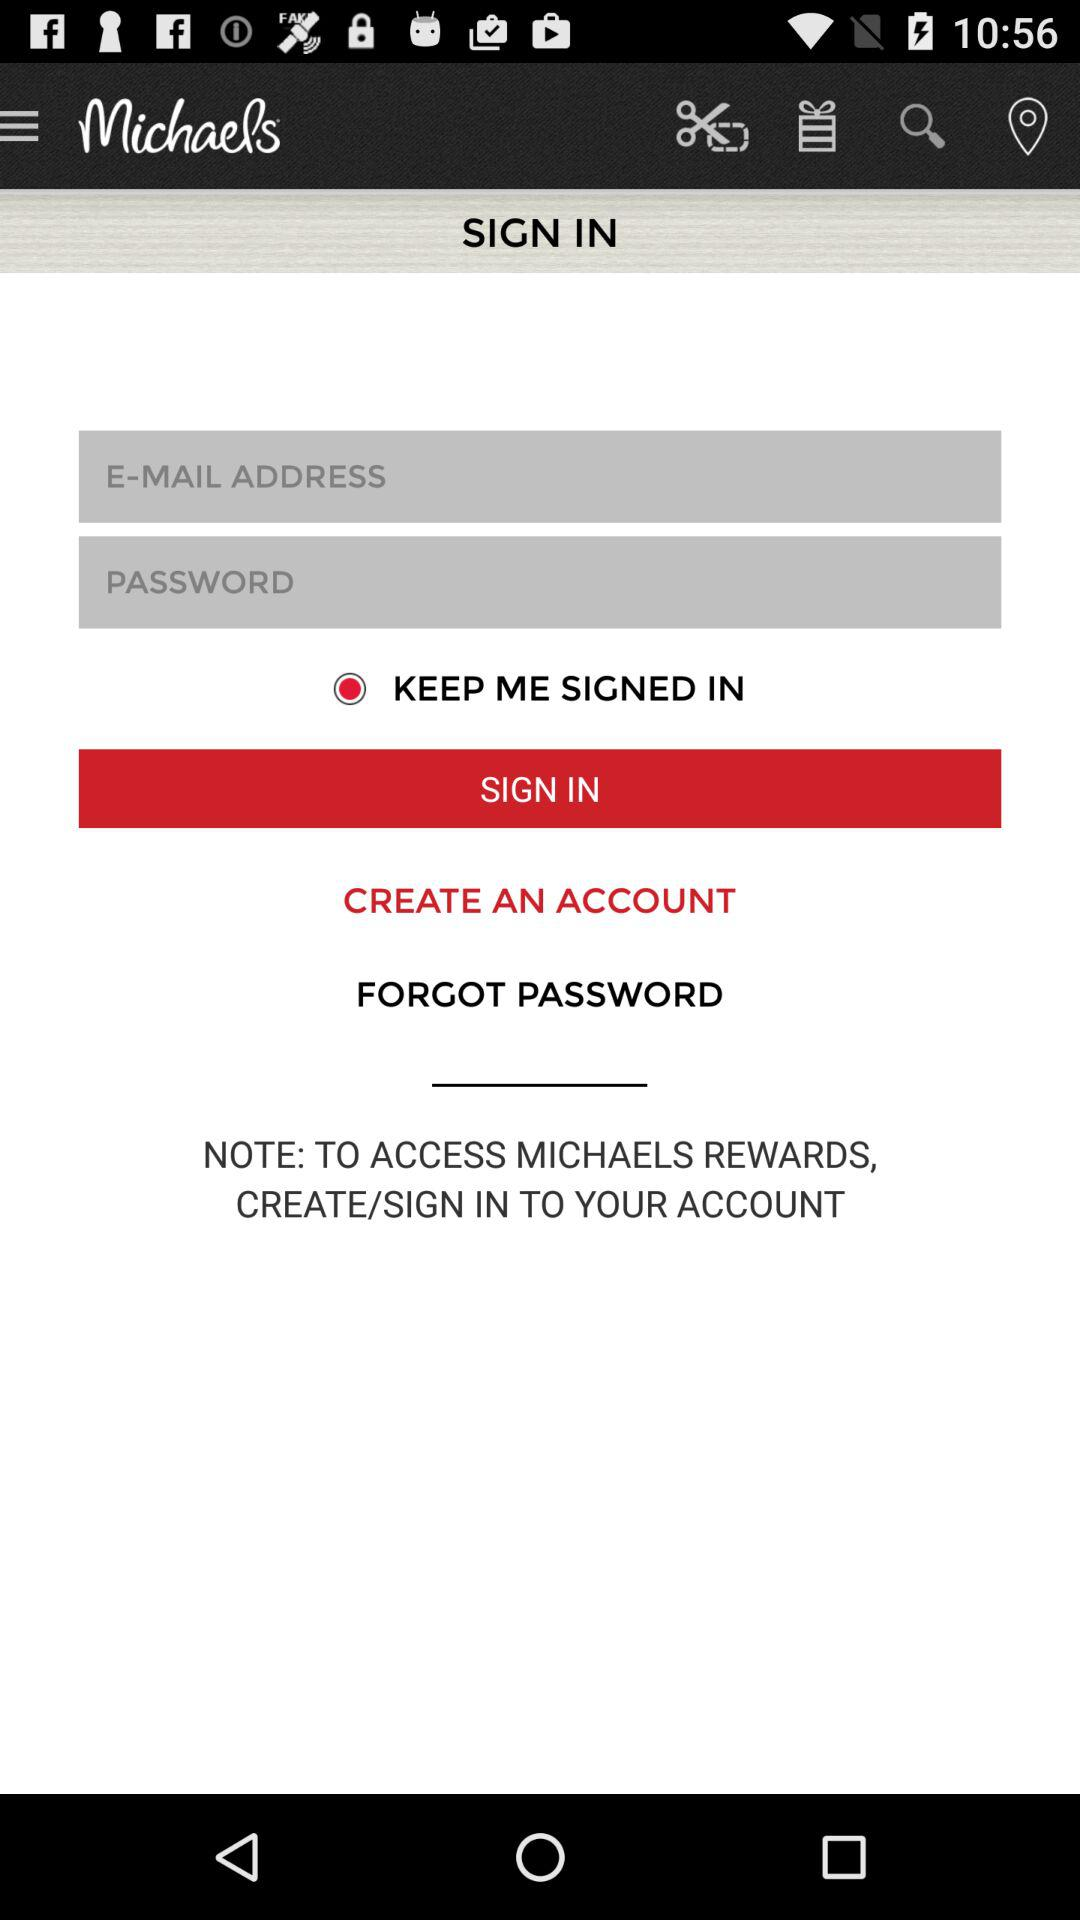What is the application name? The application name is "Michaels". 